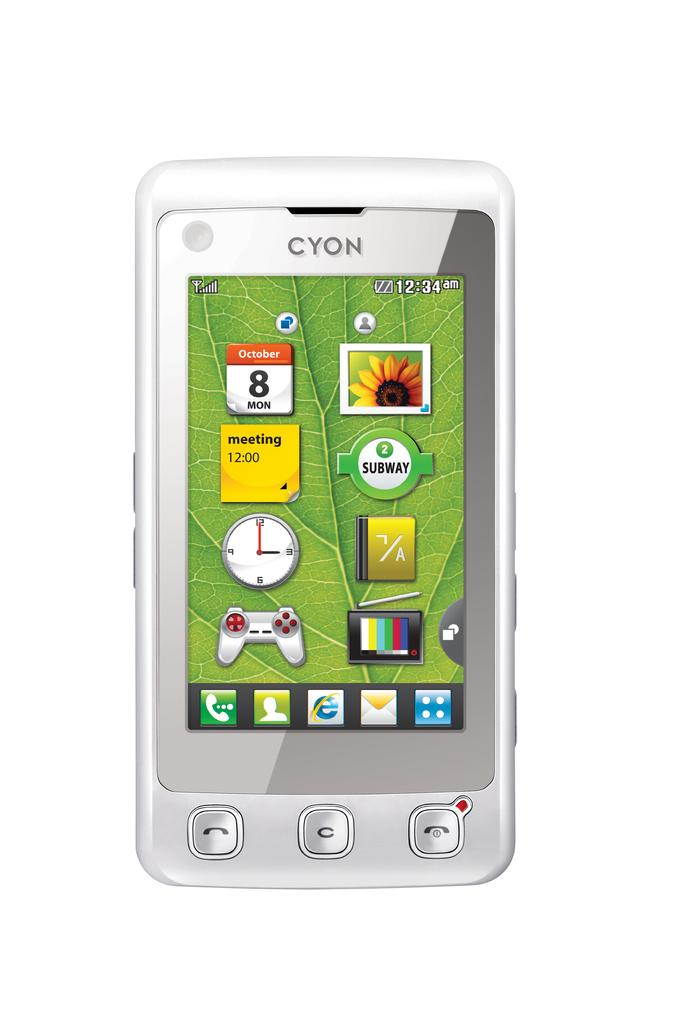<image>
Relay a brief, clear account of the picture shown. A Cyon cellphone with various icons for apps and functions. 